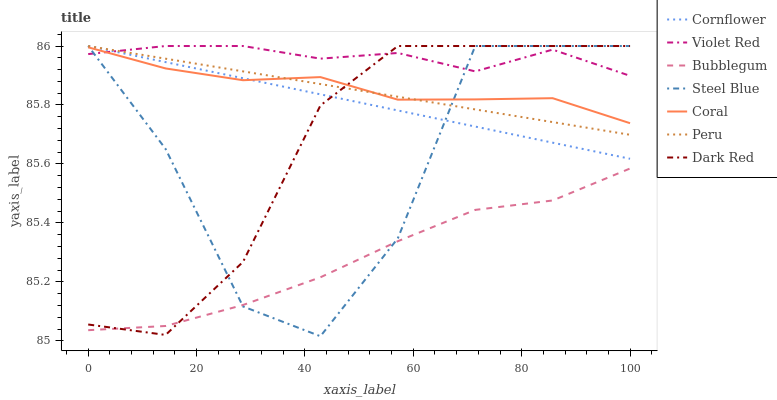Does Bubblegum have the minimum area under the curve?
Answer yes or no. Yes. Does Violet Red have the maximum area under the curve?
Answer yes or no. Yes. Does Dark Red have the minimum area under the curve?
Answer yes or no. No. Does Dark Red have the maximum area under the curve?
Answer yes or no. No. Is Peru the smoothest?
Answer yes or no. Yes. Is Steel Blue the roughest?
Answer yes or no. Yes. Is Violet Red the smoothest?
Answer yes or no. No. Is Violet Red the roughest?
Answer yes or no. No. Does Dark Red have the lowest value?
Answer yes or no. No. Does Peru have the highest value?
Answer yes or no. Yes. Does Coral have the highest value?
Answer yes or no. No. Is Bubblegum less than Cornflower?
Answer yes or no. Yes. Is Violet Red greater than Bubblegum?
Answer yes or no. Yes. Does Coral intersect Cornflower?
Answer yes or no. Yes. Is Coral less than Cornflower?
Answer yes or no. No. Is Coral greater than Cornflower?
Answer yes or no. No. Does Bubblegum intersect Cornflower?
Answer yes or no. No. 